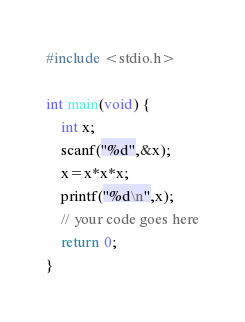Convert code to text. <code><loc_0><loc_0><loc_500><loc_500><_C_>#include <stdio.h>

int main(void) {
	int x;
	scanf("%d",&x);
	x=x*x*x;
	printf("%d\n",x);
	// your code goes here
	return 0;
}</code> 